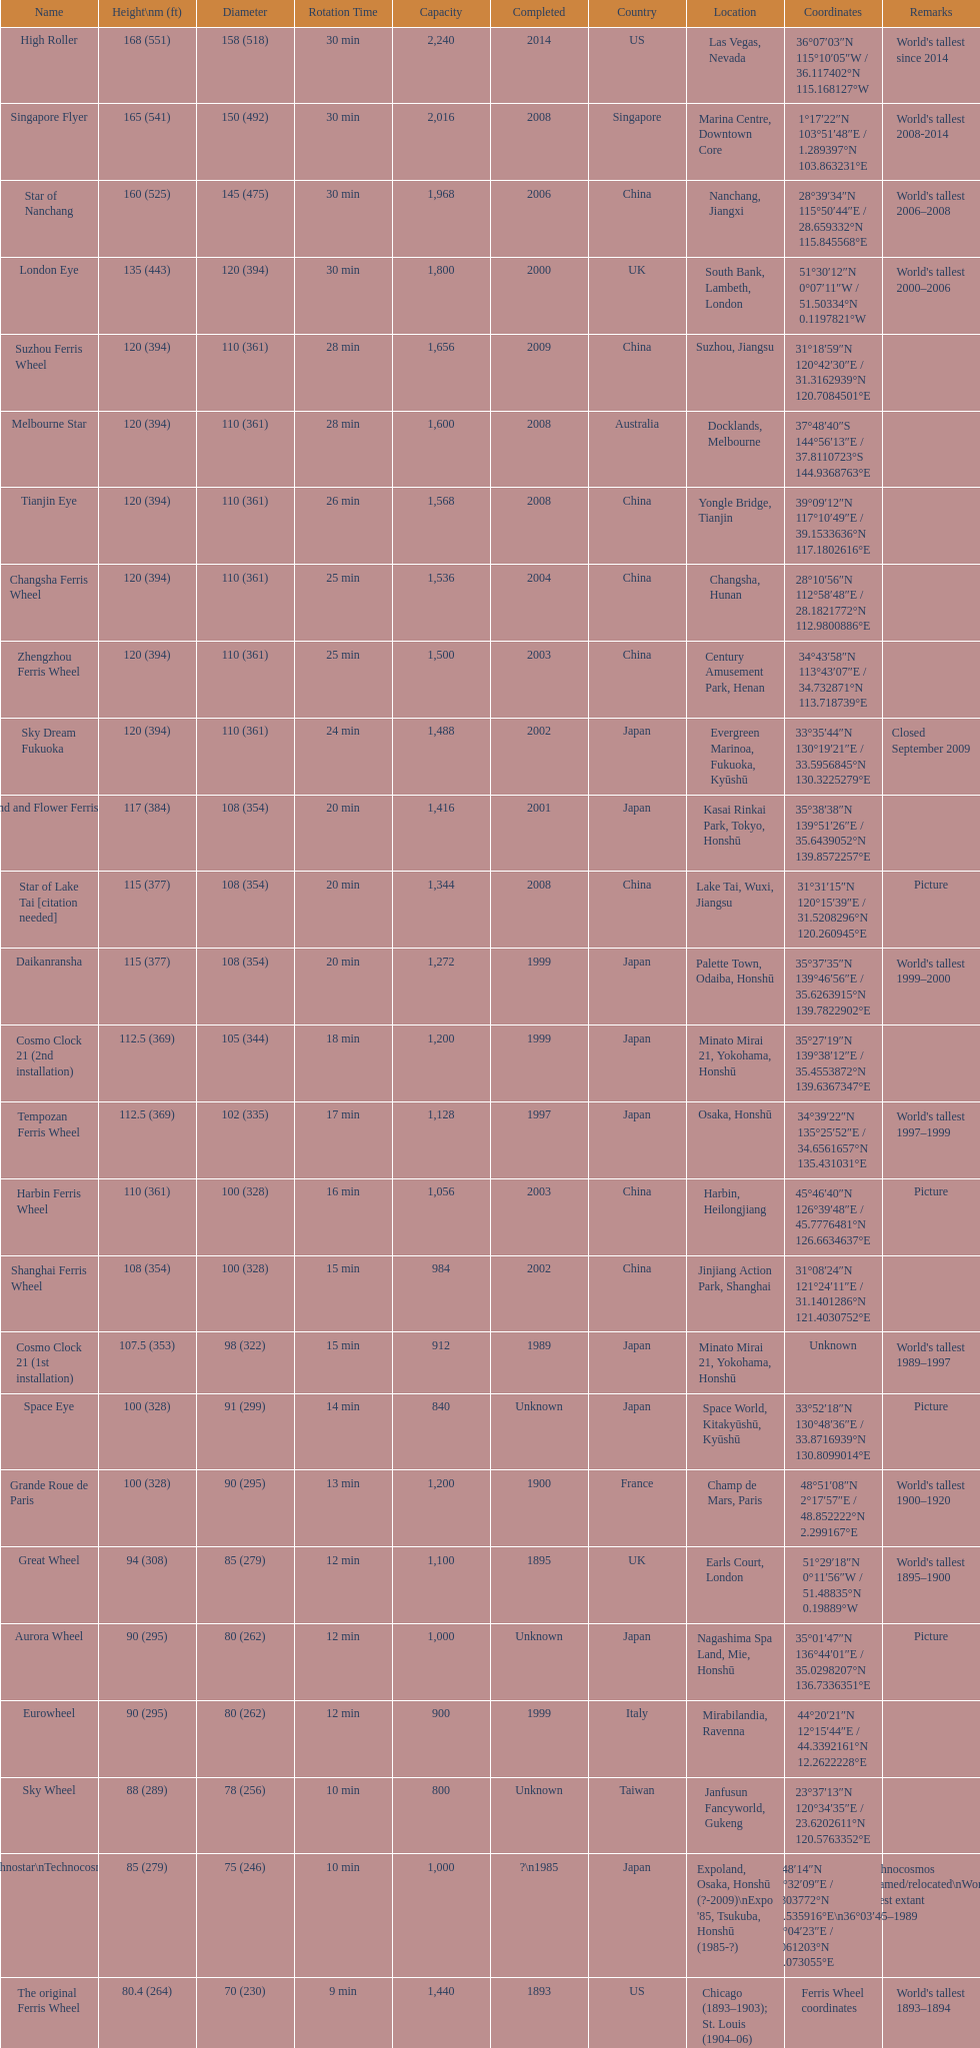Which of the following roller coasters is the oldest: star of lake tai, star of nanchang, melbourne star Star of Nanchang. 